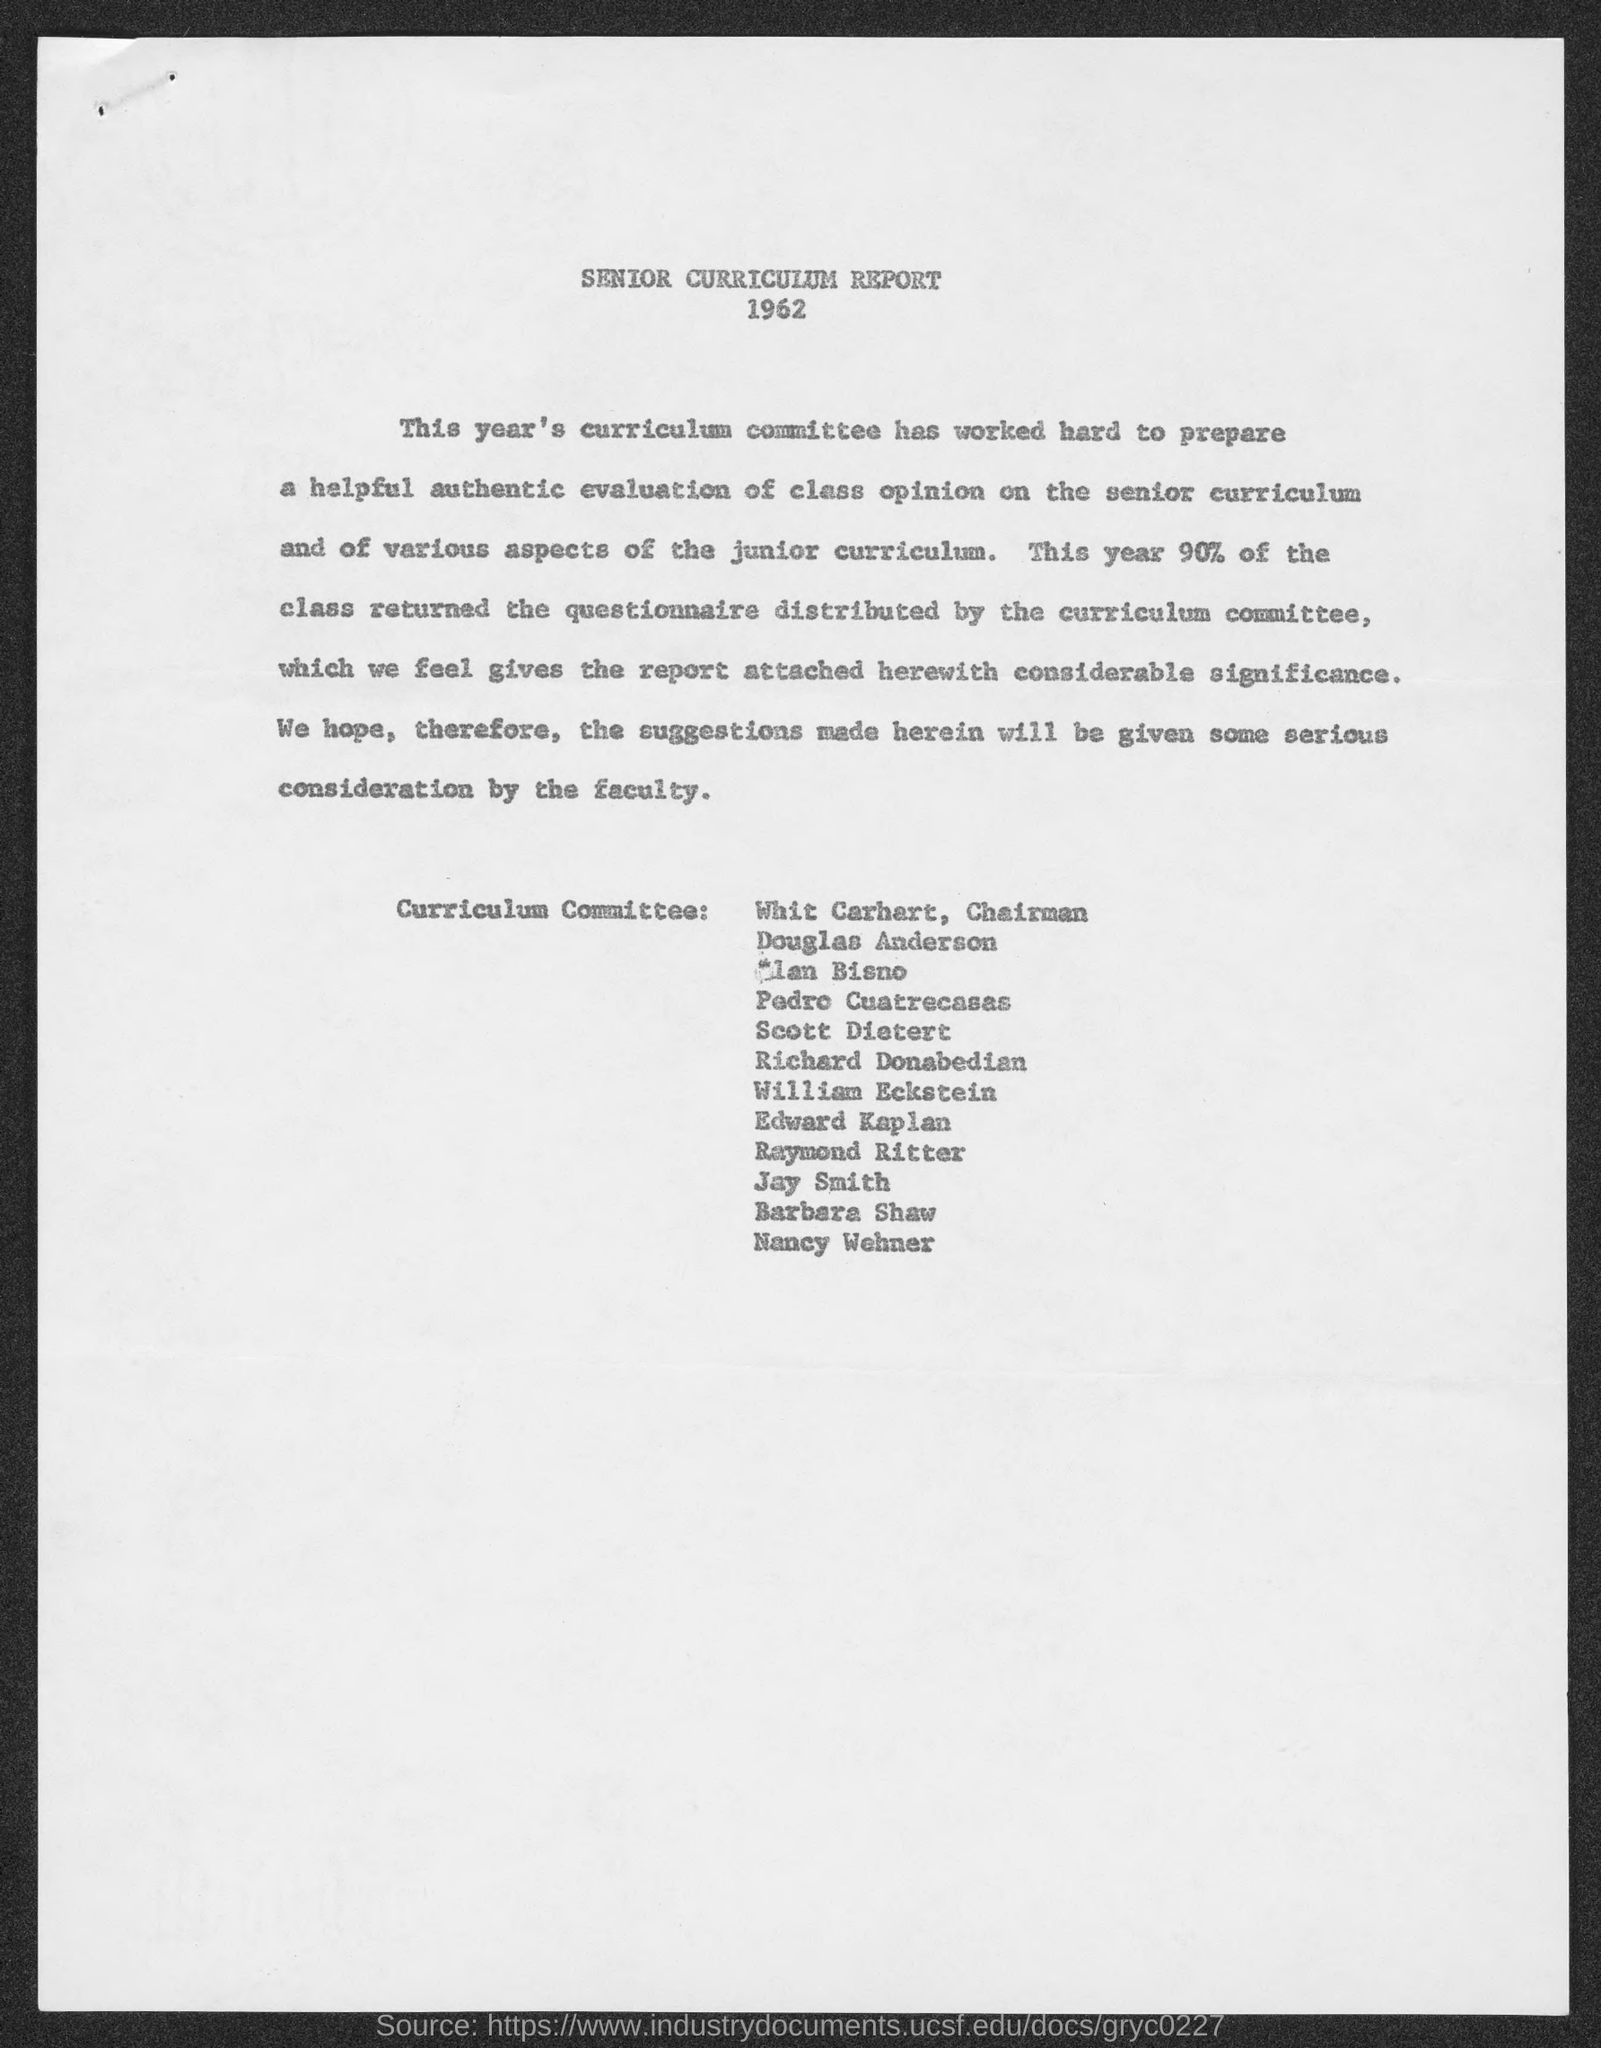Highlight a few significant elements in this photo. The chairman of the curriculum committee is Whit Carhart. 